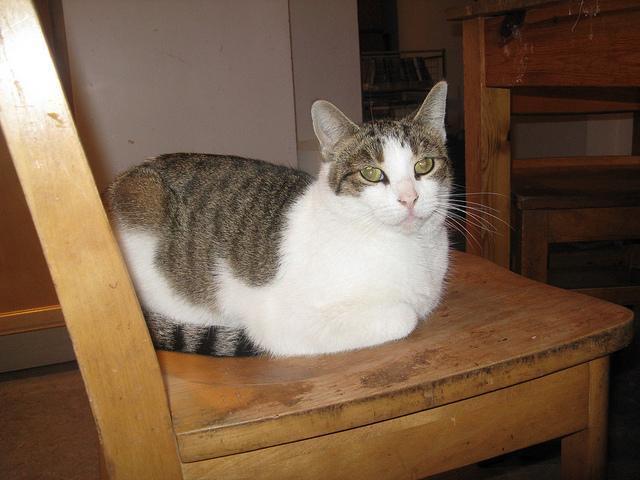How many chairs are visible?
Give a very brief answer. 2. How many white stuffed bears are there?
Give a very brief answer. 0. 